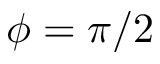Convert formula to latex. <formula><loc_0><loc_0><loc_500><loc_500>\phi = \pi / 2</formula> 